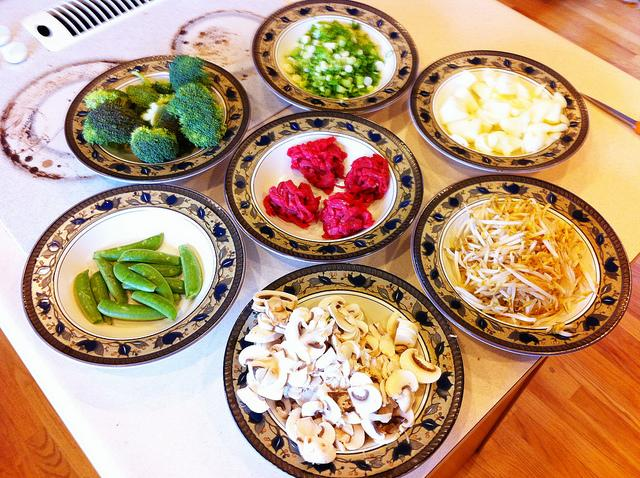How many plates are on the table? seven 